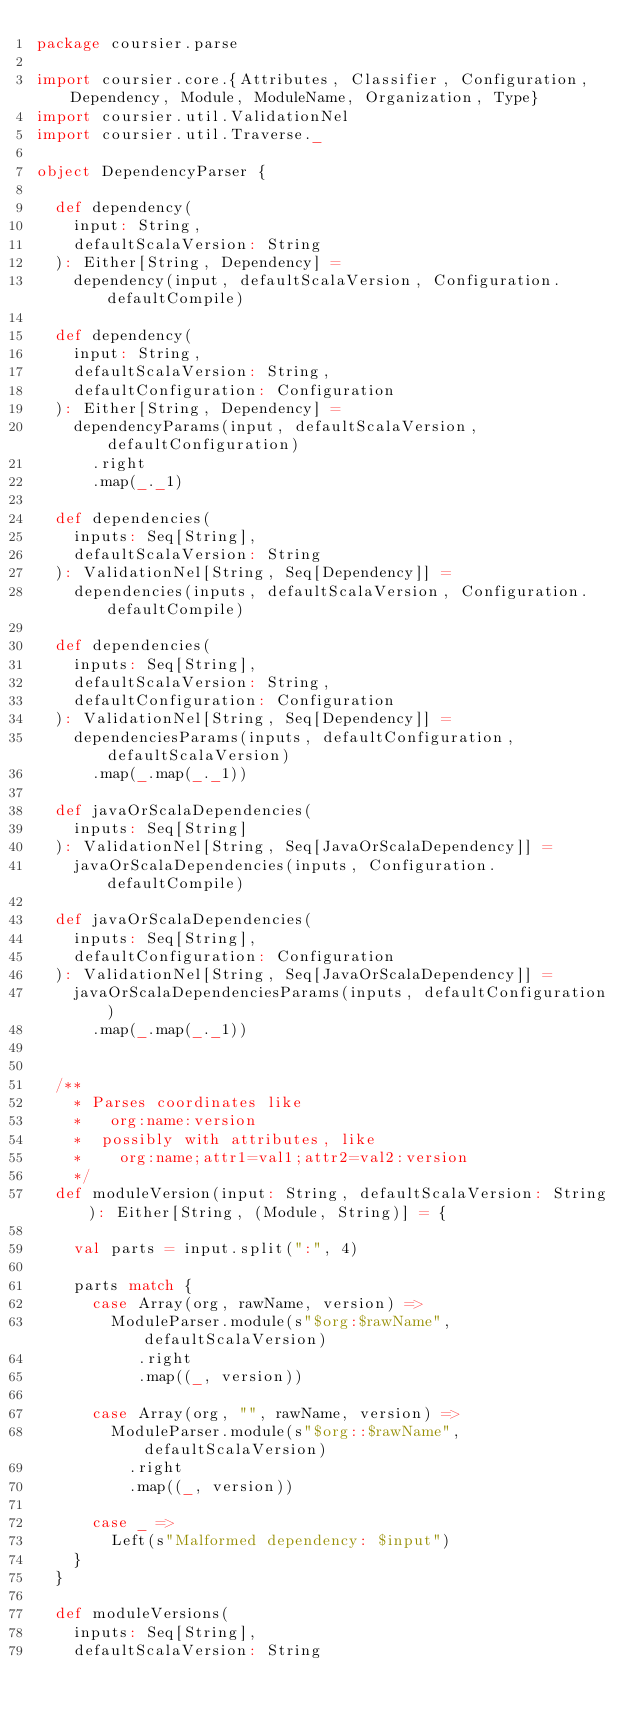<code> <loc_0><loc_0><loc_500><loc_500><_Scala_>package coursier.parse

import coursier.core.{Attributes, Classifier, Configuration, Dependency, Module, ModuleName, Organization, Type}
import coursier.util.ValidationNel
import coursier.util.Traverse._

object DependencyParser {

  def dependency(
    input: String,
    defaultScalaVersion: String
  ): Either[String, Dependency] =
    dependency(input, defaultScalaVersion, Configuration.defaultCompile)

  def dependency(
    input: String,
    defaultScalaVersion: String,
    defaultConfiguration: Configuration
  ): Either[String, Dependency] =
    dependencyParams(input, defaultScalaVersion, defaultConfiguration)
      .right
      .map(_._1)

  def dependencies(
    inputs: Seq[String],
    defaultScalaVersion: String
  ): ValidationNel[String, Seq[Dependency]] =
    dependencies(inputs, defaultScalaVersion, Configuration.defaultCompile)

  def dependencies(
    inputs: Seq[String],
    defaultScalaVersion: String,
    defaultConfiguration: Configuration
  ): ValidationNel[String, Seq[Dependency]] =
    dependenciesParams(inputs, defaultConfiguration, defaultScalaVersion)
      .map(_.map(_._1))

  def javaOrScalaDependencies(
    inputs: Seq[String]
  ): ValidationNel[String, Seq[JavaOrScalaDependency]] =
    javaOrScalaDependencies(inputs, Configuration.defaultCompile)

  def javaOrScalaDependencies(
    inputs: Seq[String],
    defaultConfiguration: Configuration
  ): ValidationNel[String, Seq[JavaOrScalaDependency]] =
    javaOrScalaDependenciesParams(inputs, defaultConfiguration)
      .map(_.map(_._1))


  /**
    * Parses coordinates like
    *   org:name:version
    *  possibly with attributes, like
    *    org:name;attr1=val1;attr2=val2:version
    */
  def moduleVersion(input: String, defaultScalaVersion: String): Either[String, (Module, String)] = {

    val parts = input.split(":", 4)

    parts match {
      case Array(org, rawName, version) =>
        ModuleParser.module(s"$org:$rawName", defaultScalaVersion)
           .right
           .map((_, version))

      case Array(org, "", rawName, version) =>
        ModuleParser.module(s"$org::$rawName", defaultScalaVersion)
          .right
          .map((_, version))

      case _ =>
        Left(s"Malformed dependency: $input")
    }
  }

  def moduleVersions(
    inputs: Seq[String],
    defaultScalaVersion: String</code> 